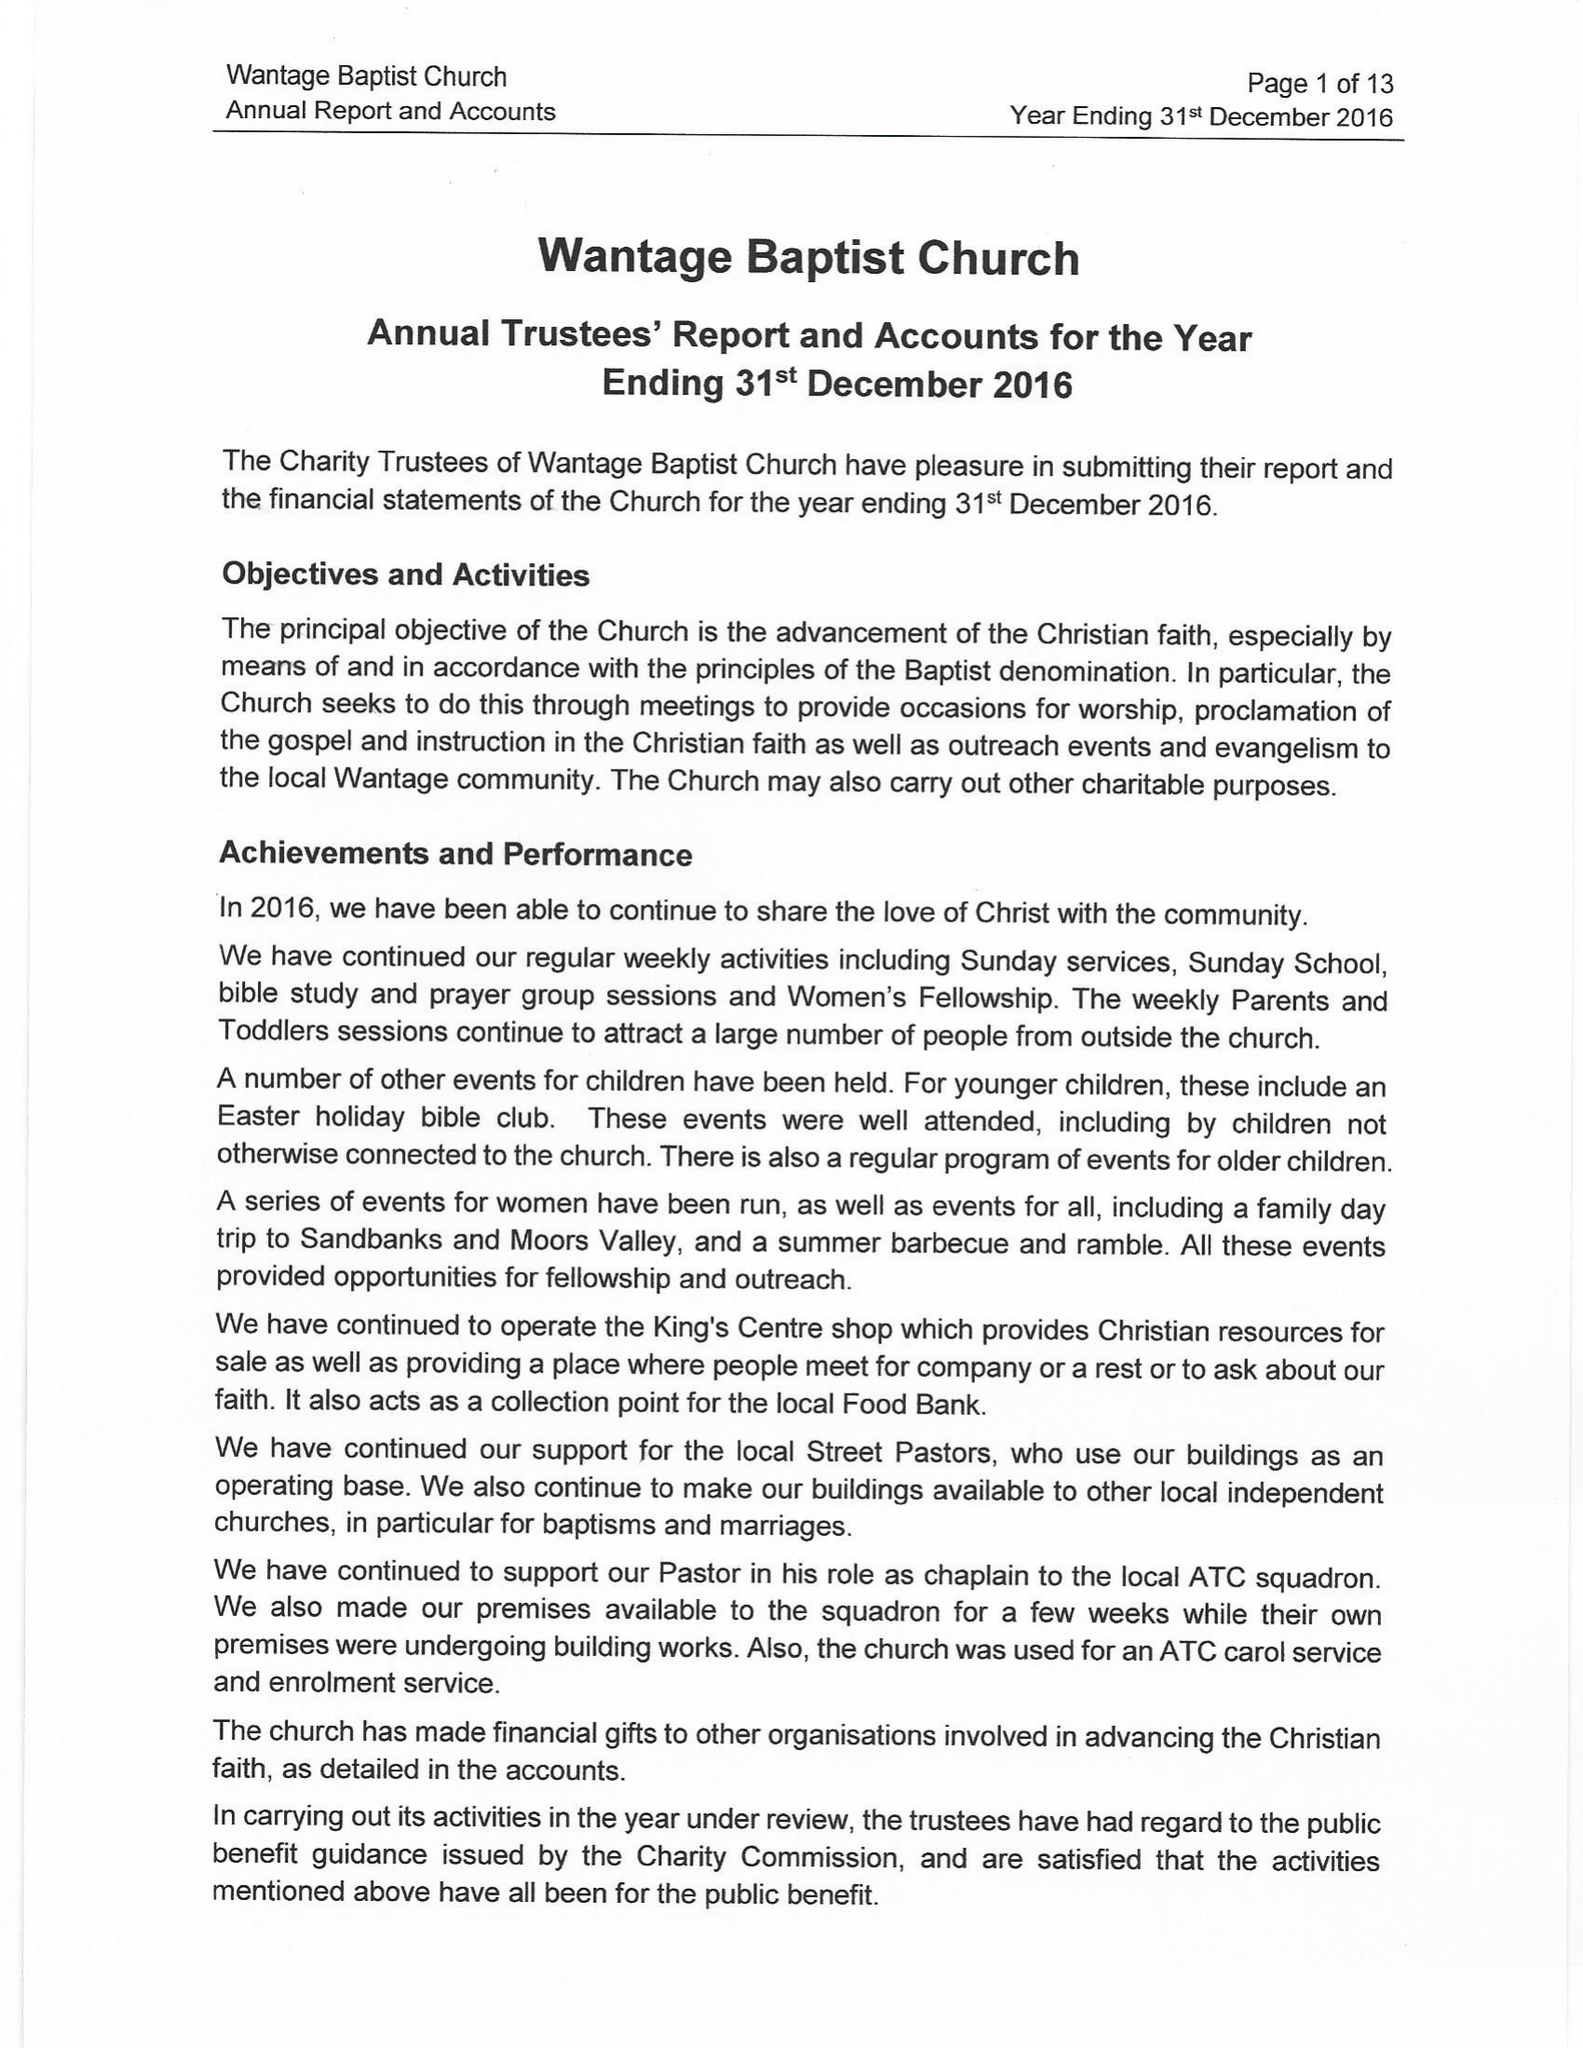What is the value for the address__post_town?
Answer the question using a single word or phrase. WANTAGE 